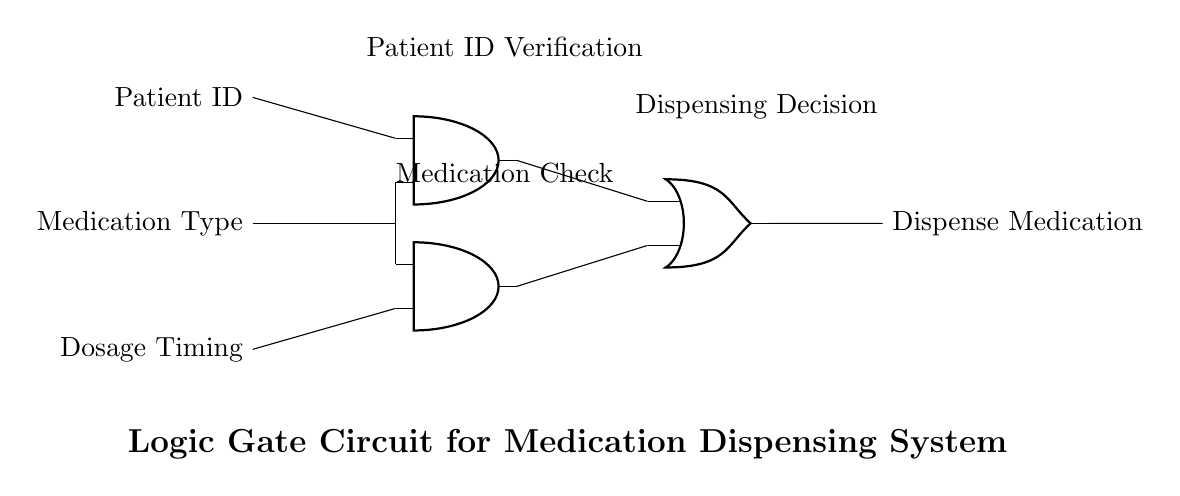What are the inputs to the circuit? The inputs to the circuit are Patient ID, Medication Type, and Dosage Timing. These are the parameters required for the logic gate circuit to function properly, ensuring correct medication dispensing.
Answer: Patient ID, Medication Type, Dosage Timing What type of logic gates are used in the circuit? The circuit includes AND gates and an OR gate. The AND gates are used for checking multiple conditions before proceeding, while the OR gate determines if either condition is sufficient to trigger the output.
Answer: AND gates, OR gate What is the output of the circuit? The output of the circuit is "Dispense Medication". This represents the action that will occur if the conditions provided by the inputs are met successfully.
Answer: Dispense Medication How many AND gates are present in the circuit? There are two AND gates present in the circuit. They are responsible for evaluating the conditions related to patient and medication specifications.
Answer: Two Which signal is connected to both AND gates? The Medication Type signal is connected to both AND gates. This means that medication verification is a critical condition for dispensing logic.
Answer: Medication Type What determines the dispensing decision in this circuit? The dispensing decision is determined by the inputs processed through the AND gates followed by the OR gate. If either AND gate produces a true output, the OR gate will trigger the dispense action.
Answer: AND gates and OR gate What does the circuit represent in a medication dispensing system? The circuit represents a logic gate mechanism designed to ensure that the correct medication is dispensed based on patient-specific information and predetermined conditions.
Answer: A logic mechanism for correct medication dispensing 